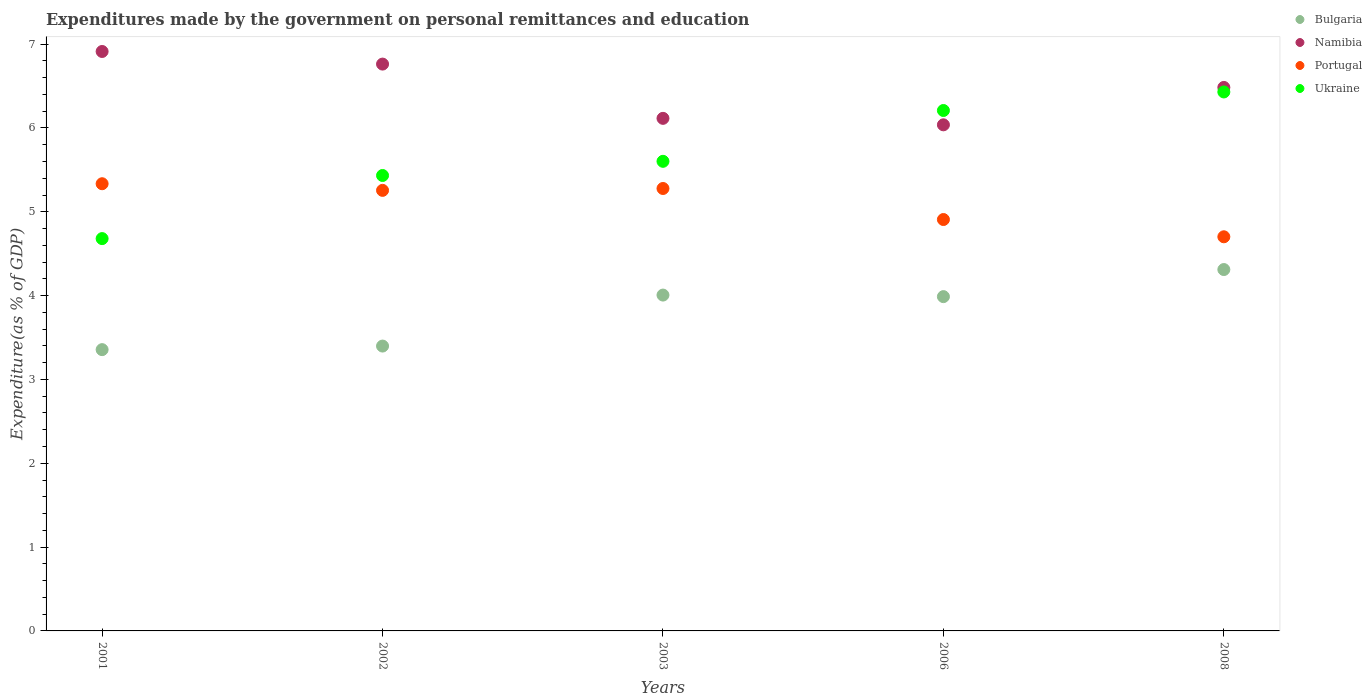How many different coloured dotlines are there?
Give a very brief answer. 4. Is the number of dotlines equal to the number of legend labels?
Make the answer very short. Yes. What is the expenditures made by the government on personal remittances and education in Bulgaria in 2008?
Give a very brief answer. 4.31. Across all years, what is the maximum expenditures made by the government on personal remittances and education in Bulgaria?
Keep it short and to the point. 4.31. Across all years, what is the minimum expenditures made by the government on personal remittances and education in Namibia?
Provide a short and direct response. 6.04. What is the total expenditures made by the government on personal remittances and education in Portugal in the graph?
Your response must be concise. 25.48. What is the difference between the expenditures made by the government on personal remittances and education in Namibia in 2002 and that in 2008?
Your answer should be compact. 0.28. What is the difference between the expenditures made by the government on personal remittances and education in Ukraine in 2003 and the expenditures made by the government on personal remittances and education in Bulgaria in 2001?
Your answer should be very brief. 2.25. What is the average expenditures made by the government on personal remittances and education in Namibia per year?
Make the answer very short. 6.46. In the year 2002, what is the difference between the expenditures made by the government on personal remittances and education in Portugal and expenditures made by the government on personal remittances and education in Namibia?
Give a very brief answer. -1.51. In how many years, is the expenditures made by the government on personal remittances and education in Ukraine greater than 6.2 %?
Your response must be concise. 2. What is the ratio of the expenditures made by the government on personal remittances and education in Bulgaria in 2002 to that in 2006?
Your answer should be compact. 0.85. Is the expenditures made by the government on personal remittances and education in Ukraine in 2001 less than that in 2002?
Your response must be concise. Yes. What is the difference between the highest and the second highest expenditures made by the government on personal remittances and education in Portugal?
Offer a very short reply. 0.06. What is the difference between the highest and the lowest expenditures made by the government on personal remittances and education in Bulgaria?
Your answer should be very brief. 0.96. Is it the case that in every year, the sum of the expenditures made by the government on personal remittances and education in Namibia and expenditures made by the government on personal remittances and education in Bulgaria  is greater than the sum of expenditures made by the government on personal remittances and education in Ukraine and expenditures made by the government on personal remittances and education in Portugal?
Your response must be concise. No. How many dotlines are there?
Offer a very short reply. 4. How many years are there in the graph?
Make the answer very short. 5. Are the values on the major ticks of Y-axis written in scientific E-notation?
Provide a short and direct response. No. Does the graph contain grids?
Provide a succinct answer. No. Where does the legend appear in the graph?
Offer a terse response. Top right. How many legend labels are there?
Keep it short and to the point. 4. What is the title of the graph?
Your response must be concise. Expenditures made by the government on personal remittances and education. Does "Saudi Arabia" appear as one of the legend labels in the graph?
Offer a terse response. No. What is the label or title of the Y-axis?
Offer a terse response. Expenditure(as % of GDP). What is the Expenditure(as % of GDP) in Bulgaria in 2001?
Your answer should be very brief. 3.36. What is the Expenditure(as % of GDP) in Namibia in 2001?
Your response must be concise. 6.91. What is the Expenditure(as % of GDP) of Portugal in 2001?
Your response must be concise. 5.34. What is the Expenditure(as % of GDP) of Ukraine in 2001?
Provide a short and direct response. 4.68. What is the Expenditure(as % of GDP) of Bulgaria in 2002?
Offer a terse response. 3.4. What is the Expenditure(as % of GDP) of Namibia in 2002?
Keep it short and to the point. 6.76. What is the Expenditure(as % of GDP) in Portugal in 2002?
Your response must be concise. 5.26. What is the Expenditure(as % of GDP) of Ukraine in 2002?
Give a very brief answer. 5.43. What is the Expenditure(as % of GDP) in Bulgaria in 2003?
Keep it short and to the point. 4.01. What is the Expenditure(as % of GDP) of Namibia in 2003?
Your answer should be compact. 6.12. What is the Expenditure(as % of GDP) of Portugal in 2003?
Provide a succinct answer. 5.28. What is the Expenditure(as % of GDP) of Ukraine in 2003?
Offer a terse response. 5.6. What is the Expenditure(as % of GDP) of Bulgaria in 2006?
Provide a short and direct response. 3.99. What is the Expenditure(as % of GDP) in Namibia in 2006?
Keep it short and to the point. 6.04. What is the Expenditure(as % of GDP) in Portugal in 2006?
Your answer should be very brief. 4.91. What is the Expenditure(as % of GDP) of Ukraine in 2006?
Your answer should be very brief. 6.21. What is the Expenditure(as % of GDP) in Bulgaria in 2008?
Make the answer very short. 4.31. What is the Expenditure(as % of GDP) of Namibia in 2008?
Provide a short and direct response. 6.48. What is the Expenditure(as % of GDP) of Portugal in 2008?
Your answer should be very brief. 4.7. What is the Expenditure(as % of GDP) in Ukraine in 2008?
Make the answer very short. 6.43. Across all years, what is the maximum Expenditure(as % of GDP) in Bulgaria?
Give a very brief answer. 4.31. Across all years, what is the maximum Expenditure(as % of GDP) of Namibia?
Give a very brief answer. 6.91. Across all years, what is the maximum Expenditure(as % of GDP) in Portugal?
Your answer should be very brief. 5.34. Across all years, what is the maximum Expenditure(as % of GDP) of Ukraine?
Keep it short and to the point. 6.43. Across all years, what is the minimum Expenditure(as % of GDP) of Bulgaria?
Make the answer very short. 3.36. Across all years, what is the minimum Expenditure(as % of GDP) in Namibia?
Make the answer very short. 6.04. Across all years, what is the minimum Expenditure(as % of GDP) of Portugal?
Keep it short and to the point. 4.7. Across all years, what is the minimum Expenditure(as % of GDP) in Ukraine?
Your response must be concise. 4.68. What is the total Expenditure(as % of GDP) of Bulgaria in the graph?
Your response must be concise. 19.06. What is the total Expenditure(as % of GDP) in Namibia in the graph?
Your response must be concise. 32.31. What is the total Expenditure(as % of GDP) of Portugal in the graph?
Offer a terse response. 25.48. What is the total Expenditure(as % of GDP) in Ukraine in the graph?
Your answer should be very brief. 28.35. What is the difference between the Expenditure(as % of GDP) in Bulgaria in 2001 and that in 2002?
Provide a succinct answer. -0.04. What is the difference between the Expenditure(as % of GDP) in Namibia in 2001 and that in 2002?
Your answer should be compact. 0.15. What is the difference between the Expenditure(as % of GDP) in Portugal in 2001 and that in 2002?
Ensure brevity in your answer.  0.08. What is the difference between the Expenditure(as % of GDP) in Ukraine in 2001 and that in 2002?
Keep it short and to the point. -0.75. What is the difference between the Expenditure(as % of GDP) of Bulgaria in 2001 and that in 2003?
Your response must be concise. -0.65. What is the difference between the Expenditure(as % of GDP) in Namibia in 2001 and that in 2003?
Your answer should be compact. 0.8. What is the difference between the Expenditure(as % of GDP) of Portugal in 2001 and that in 2003?
Your answer should be very brief. 0.06. What is the difference between the Expenditure(as % of GDP) in Ukraine in 2001 and that in 2003?
Offer a very short reply. -0.92. What is the difference between the Expenditure(as % of GDP) of Bulgaria in 2001 and that in 2006?
Keep it short and to the point. -0.63. What is the difference between the Expenditure(as % of GDP) in Portugal in 2001 and that in 2006?
Give a very brief answer. 0.43. What is the difference between the Expenditure(as % of GDP) in Ukraine in 2001 and that in 2006?
Keep it short and to the point. -1.53. What is the difference between the Expenditure(as % of GDP) in Bulgaria in 2001 and that in 2008?
Provide a short and direct response. -0.96. What is the difference between the Expenditure(as % of GDP) in Namibia in 2001 and that in 2008?
Offer a very short reply. 0.43. What is the difference between the Expenditure(as % of GDP) in Portugal in 2001 and that in 2008?
Offer a terse response. 0.63. What is the difference between the Expenditure(as % of GDP) of Ukraine in 2001 and that in 2008?
Your answer should be very brief. -1.75. What is the difference between the Expenditure(as % of GDP) in Bulgaria in 2002 and that in 2003?
Offer a very short reply. -0.61. What is the difference between the Expenditure(as % of GDP) of Namibia in 2002 and that in 2003?
Offer a very short reply. 0.65. What is the difference between the Expenditure(as % of GDP) of Portugal in 2002 and that in 2003?
Provide a succinct answer. -0.02. What is the difference between the Expenditure(as % of GDP) in Ukraine in 2002 and that in 2003?
Offer a terse response. -0.17. What is the difference between the Expenditure(as % of GDP) in Bulgaria in 2002 and that in 2006?
Offer a terse response. -0.59. What is the difference between the Expenditure(as % of GDP) in Namibia in 2002 and that in 2006?
Provide a short and direct response. 0.72. What is the difference between the Expenditure(as % of GDP) of Portugal in 2002 and that in 2006?
Provide a short and direct response. 0.35. What is the difference between the Expenditure(as % of GDP) in Ukraine in 2002 and that in 2006?
Provide a short and direct response. -0.78. What is the difference between the Expenditure(as % of GDP) of Bulgaria in 2002 and that in 2008?
Make the answer very short. -0.91. What is the difference between the Expenditure(as % of GDP) of Namibia in 2002 and that in 2008?
Provide a short and direct response. 0.28. What is the difference between the Expenditure(as % of GDP) of Portugal in 2002 and that in 2008?
Your response must be concise. 0.55. What is the difference between the Expenditure(as % of GDP) in Ukraine in 2002 and that in 2008?
Your answer should be compact. -1. What is the difference between the Expenditure(as % of GDP) of Bulgaria in 2003 and that in 2006?
Give a very brief answer. 0.02. What is the difference between the Expenditure(as % of GDP) of Namibia in 2003 and that in 2006?
Provide a short and direct response. 0.08. What is the difference between the Expenditure(as % of GDP) of Portugal in 2003 and that in 2006?
Provide a short and direct response. 0.37. What is the difference between the Expenditure(as % of GDP) of Ukraine in 2003 and that in 2006?
Your response must be concise. -0.61. What is the difference between the Expenditure(as % of GDP) of Bulgaria in 2003 and that in 2008?
Ensure brevity in your answer.  -0.3. What is the difference between the Expenditure(as % of GDP) of Namibia in 2003 and that in 2008?
Offer a terse response. -0.37. What is the difference between the Expenditure(as % of GDP) of Portugal in 2003 and that in 2008?
Give a very brief answer. 0.58. What is the difference between the Expenditure(as % of GDP) in Ukraine in 2003 and that in 2008?
Your answer should be very brief. -0.83. What is the difference between the Expenditure(as % of GDP) of Bulgaria in 2006 and that in 2008?
Offer a terse response. -0.32. What is the difference between the Expenditure(as % of GDP) of Namibia in 2006 and that in 2008?
Your answer should be compact. -0.45. What is the difference between the Expenditure(as % of GDP) in Portugal in 2006 and that in 2008?
Offer a very short reply. 0.21. What is the difference between the Expenditure(as % of GDP) of Ukraine in 2006 and that in 2008?
Your answer should be very brief. -0.22. What is the difference between the Expenditure(as % of GDP) of Bulgaria in 2001 and the Expenditure(as % of GDP) of Namibia in 2002?
Your answer should be very brief. -3.41. What is the difference between the Expenditure(as % of GDP) of Bulgaria in 2001 and the Expenditure(as % of GDP) of Portugal in 2002?
Provide a succinct answer. -1.9. What is the difference between the Expenditure(as % of GDP) in Bulgaria in 2001 and the Expenditure(as % of GDP) in Ukraine in 2002?
Keep it short and to the point. -2.08. What is the difference between the Expenditure(as % of GDP) of Namibia in 2001 and the Expenditure(as % of GDP) of Portugal in 2002?
Ensure brevity in your answer.  1.66. What is the difference between the Expenditure(as % of GDP) in Namibia in 2001 and the Expenditure(as % of GDP) in Ukraine in 2002?
Give a very brief answer. 1.48. What is the difference between the Expenditure(as % of GDP) of Portugal in 2001 and the Expenditure(as % of GDP) of Ukraine in 2002?
Keep it short and to the point. -0.1. What is the difference between the Expenditure(as % of GDP) in Bulgaria in 2001 and the Expenditure(as % of GDP) in Namibia in 2003?
Offer a terse response. -2.76. What is the difference between the Expenditure(as % of GDP) of Bulgaria in 2001 and the Expenditure(as % of GDP) of Portugal in 2003?
Offer a terse response. -1.92. What is the difference between the Expenditure(as % of GDP) of Bulgaria in 2001 and the Expenditure(as % of GDP) of Ukraine in 2003?
Your response must be concise. -2.25. What is the difference between the Expenditure(as % of GDP) in Namibia in 2001 and the Expenditure(as % of GDP) in Portugal in 2003?
Keep it short and to the point. 1.63. What is the difference between the Expenditure(as % of GDP) of Namibia in 2001 and the Expenditure(as % of GDP) of Ukraine in 2003?
Your answer should be very brief. 1.31. What is the difference between the Expenditure(as % of GDP) of Portugal in 2001 and the Expenditure(as % of GDP) of Ukraine in 2003?
Your answer should be very brief. -0.27. What is the difference between the Expenditure(as % of GDP) of Bulgaria in 2001 and the Expenditure(as % of GDP) of Namibia in 2006?
Ensure brevity in your answer.  -2.68. What is the difference between the Expenditure(as % of GDP) of Bulgaria in 2001 and the Expenditure(as % of GDP) of Portugal in 2006?
Provide a succinct answer. -1.55. What is the difference between the Expenditure(as % of GDP) of Bulgaria in 2001 and the Expenditure(as % of GDP) of Ukraine in 2006?
Your answer should be very brief. -2.85. What is the difference between the Expenditure(as % of GDP) of Namibia in 2001 and the Expenditure(as % of GDP) of Portugal in 2006?
Keep it short and to the point. 2. What is the difference between the Expenditure(as % of GDP) in Namibia in 2001 and the Expenditure(as % of GDP) in Ukraine in 2006?
Your answer should be very brief. 0.7. What is the difference between the Expenditure(as % of GDP) of Portugal in 2001 and the Expenditure(as % of GDP) of Ukraine in 2006?
Keep it short and to the point. -0.87. What is the difference between the Expenditure(as % of GDP) of Bulgaria in 2001 and the Expenditure(as % of GDP) of Namibia in 2008?
Your answer should be very brief. -3.13. What is the difference between the Expenditure(as % of GDP) of Bulgaria in 2001 and the Expenditure(as % of GDP) of Portugal in 2008?
Keep it short and to the point. -1.35. What is the difference between the Expenditure(as % of GDP) in Bulgaria in 2001 and the Expenditure(as % of GDP) in Ukraine in 2008?
Your answer should be very brief. -3.07. What is the difference between the Expenditure(as % of GDP) in Namibia in 2001 and the Expenditure(as % of GDP) in Portugal in 2008?
Your answer should be compact. 2.21. What is the difference between the Expenditure(as % of GDP) of Namibia in 2001 and the Expenditure(as % of GDP) of Ukraine in 2008?
Your answer should be compact. 0.48. What is the difference between the Expenditure(as % of GDP) of Portugal in 2001 and the Expenditure(as % of GDP) of Ukraine in 2008?
Offer a very short reply. -1.09. What is the difference between the Expenditure(as % of GDP) of Bulgaria in 2002 and the Expenditure(as % of GDP) of Namibia in 2003?
Provide a short and direct response. -2.72. What is the difference between the Expenditure(as % of GDP) of Bulgaria in 2002 and the Expenditure(as % of GDP) of Portugal in 2003?
Your answer should be very brief. -1.88. What is the difference between the Expenditure(as % of GDP) in Bulgaria in 2002 and the Expenditure(as % of GDP) in Ukraine in 2003?
Your answer should be compact. -2.2. What is the difference between the Expenditure(as % of GDP) in Namibia in 2002 and the Expenditure(as % of GDP) in Portugal in 2003?
Offer a terse response. 1.48. What is the difference between the Expenditure(as % of GDP) of Namibia in 2002 and the Expenditure(as % of GDP) of Ukraine in 2003?
Provide a short and direct response. 1.16. What is the difference between the Expenditure(as % of GDP) in Portugal in 2002 and the Expenditure(as % of GDP) in Ukraine in 2003?
Your answer should be compact. -0.35. What is the difference between the Expenditure(as % of GDP) in Bulgaria in 2002 and the Expenditure(as % of GDP) in Namibia in 2006?
Provide a succinct answer. -2.64. What is the difference between the Expenditure(as % of GDP) in Bulgaria in 2002 and the Expenditure(as % of GDP) in Portugal in 2006?
Keep it short and to the point. -1.51. What is the difference between the Expenditure(as % of GDP) in Bulgaria in 2002 and the Expenditure(as % of GDP) in Ukraine in 2006?
Offer a terse response. -2.81. What is the difference between the Expenditure(as % of GDP) of Namibia in 2002 and the Expenditure(as % of GDP) of Portugal in 2006?
Offer a terse response. 1.85. What is the difference between the Expenditure(as % of GDP) of Namibia in 2002 and the Expenditure(as % of GDP) of Ukraine in 2006?
Your answer should be very brief. 0.55. What is the difference between the Expenditure(as % of GDP) of Portugal in 2002 and the Expenditure(as % of GDP) of Ukraine in 2006?
Provide a succinct answer. -0.95. What is the difference between the Expenditure(as % of GDP) of Bulgaria in 2002 and the Expenditure(as % of GDP) of Namibia in 2008?
Give a very brief answer. -3.09. What is the difference between the Expenditure(as % of GDP) of Bulgaria in 2002 and the Expenditure(as % of GDP) of Portugal in 2008?
Offer a very short reply. -1.3. What is the difference between the Expenditure(as % of GDP) in Bulgaria in 2002 and the Expenditure(as % of GDP) in Ukraine in 2008?
Offer a very short reply. -3.03. What is the difference between the Expenditure(as % of GDP) of Namibia in 2002 and the Expenditure(as % of GDP) of Portugal in 2008?
Provide a succinct answer. 2.06. What is the difference between the Expenditure(as % of GDP) of Namibia in 2002 and the Expenditure(as % of GDP) of Ukraine in 2008?
Your answer should be compact. 0.33. What is the difference between the Expenditure(as % of GDP) of Portugal in 2002 and the Expenditure(as % of GDP) of Ukraine in 2008?
Your answer should be very brief. -1.17. What is the difference between the Expenditure(as % of GDP) in Bulgaria in 2003 and the Expenditure(as % of GDP) in Namibia in 2006?
Give a very brief answer. -2.03. What is the difference between the Expenditure(as % of GDP) of Bulgaria in 2003 and the Expenditure(as % of GDP) of Portugal in 2006?
Your answer should be very brief. -0.9. What is the difference between the Expenditure(as % of GDP) of Bulgaria in 2003 and the Expenditure(as % of GDP) of Ukraine in 2006?
Offer a terse response. -2.2. What is the difference between the Expenditure(as % of GDP) of Namibia in 2003 and the Expenditure(as % of GDP) of Portugal in 2006?
Keep it short and to the point. 1.21. What is the difference between the Expenditure(as % of GDP) of Namibia in 2003 and the Expenditure(as % of GDP) of Ukraine in 2006?
Your response must be concise. -0.09. What is the difference between the Expenditure(as % of GDP) of Portugal in 2003 and the Expenditure(as % of GDP) of Ukraine in 2006?
Keep it short and to the point. -0.93. What is the difference between the Expenditure(as % of GDP) of Bulgaria in 2003 and the Expenditure(as % of GDP) of Namibia in 2008?
Offer a very short reply. -2.48. What is the difference between the Expenditure(as % of GDP) in Bulgaria in 2003 and the Expenditure(as % of GDP) in Portugal in 2008?
Give a very brief answer. -0.7. What is the difference between the Expenditure(as % of GDP) of Bulgaria in 2003 and the Expenditure(as % of GDP) of Ukraine in 2008?
Offer a very short reply. -2.42. What is the difference between the Expenditure(as % of GDP) in Namibia in 2003 and the Expenditure(as % of GDP) in Portugal in 2008?
Provide a succinct answer. 1.41. What is the difference between the Expenditure(as % of GDP) in Namibia in 2003 and the Expenditure(as % of GDP) in Ukraine in 2008?
Your answer should be compact. -0.31. What is the difference between the Expenditure(as % of GDP) of Portugal in 2003 and the Expenditure(as % of GDP) of Ukraine in 2008?
Ensure brevity in your answer.  -1.15. What is the difference between the Expenditure(as % of GDP) in Bulgaria in 2006 and the Expenditure(as % of GDP) in Namibia in 2008?
Give a very brief answer. -2.5. What is the difference between the Expenditure(as % of GDP) in Bulgaria in 2006 and the Expenditure(as % of GDP) in Portugal in 2008?
Your response must be concise. -0.71. What is the difference between the Expenditure(as % of GDP) in Bulgaria in 2006 and the Expenditure(as % of GDP) in Ukraine in 2008?
Your answer should be compact. -2.44. What is the difference between the Expenditure(as % of GDP) in Namibia in 2006 and the Expenditure(as % of GDP) in Portugal in 2008?
Make the answer very short. 1.34. What is the difference between the Expenditure(as % of GDP) in Namibia in 2006 and the Expenditure(as % of GDP) in Ukraine in 2008?
Your response must be concise. -0.39. What is the difference between the Expenditure(as % of GDP) in Portugal in 2006 and the Expenditure(as % of GDP) in Ukraine in 2008?
Provide a succinct answer. -1.52. What is the average Expenditure(as % of GDP) of Bulgaria per year?
Ensure brevity in your answer.  3.81. What is the average Expenditure(as % of GDP) of Namibia per year?
Your answer should be compact. 6.46. What is the average Expenditure(as % of GDP) in Portugal per year?
Your answer should be very brief. 5.1. What is the average Expenditure(as % of GDP) of Ukraine per year?
Your response must be concise. 5.67. In the year 2001, what is the difference between the Expenditure(as % of GDP) in Bulgaria and Expenditure(as % of GDP) in Namibia?
Your answer should be very brief. -3.56. In the year 2001, what is the difference between the Expenditure(as % of GDP) of Bulgaria and Expenditure(as % of GDP) of Portugal?
Your answer should be very brief. -1.98. In the year 2001, what is the difference between the Expenditure(as % of GDP) in Bulgaria and Expenditure(as % of GDP) in Ukraine?
Provide a short and direct response. -1.32. In the year 2001, what is the difference between the Expenditure(as % of GDP) of Namibia and Expenditure(as % of GDP) of Portugal?
Your answer should be very brief. 1.58. In the year 2001, what is the difference between the Expenditure(as % of GDP) in Namibia and Expenditure(as % of GDP) in Ukraine?
Keep it short and to the point. 2.23. In the year 2001, what is the difference between the Expenditure(as % of GDP) of Portugal and Expenditure(as % of GDP) of Ukraine?
Offer a terse response. 0.65. In the year 2002, what is the difference between the Expenditure(as % of GDP) in Bulgaria and Expenditure(as % of GDP) in Namibia?
Give a very brief answer. -3.36. In the year 2002, what is the difference between the Expenditure(as % of GDP) in Bulgaria and Expenditure(as % of GDP) in Portugal?
Make the answer very short. -1.86. In the year 2002, what is the difference between the Expenditure(as % of GDP) of Bulgaria and Expenditure(as % of GDP) of Ukraine?
Provide a succinct answer. -2.03. In the year 2002, what is the difference between the Expenditure(as % of GDP) of Namibia and Expenditure(as % of GDP) of Portugal?
Provide a succinct answer. 1.51. In the year 2002, what is the difference between the Expenditure(as % of GDP) in Namibia and Expenditure(as % of GDP) in Ukraine?
Offer a very short reply. 1.33. In the year 2002, what is the difference between the Expenditure(as % of GDP) in Portugal and Expenditure(as % of GDP) in Ukraine?
Give a very brief answer. -0.18. In the year 2003, what is the difference between the Expenditure(as % of GDP) in Bulgaria and Expenditure(as % of GDP) in Namibia?
Make the answer very short. -2.11. In the year 2003, what is the difference between the Expenditure(as % of GDP) of Bulgaria and Expenditure(as % of GDP) of Portugal?
Keep it short and to the point. -1.27. In the year 2003, what is the difference between the Expenditure(as % of GDP) in Bulgaria and Expenditure(as % of GDP) in Ukraine?
Make the answer very short. -1.6. In the year 2003, what is the difference between the Expenditure(as % of GDP) of Namibia and Expenditure(as % of GDP) of Portugal?
Provide a succinct answer. 0.84. In the year 2003, what is the difference between the Expenditure(as % of GDP) in Namibia and Expenditure(as % of GDP) in Ukraine?
Make the answer very short. 0.51. In the year 2003, what is the difference between the Expenditure(as % of GDP) in Portugal and Expenditure(as % of GDP) in Ukraine?
Provide a succinct answer. -0.32. In the year 2006, what is the difference between the Expenditure(as % of GDP) in Bulgaria and Expenditure(as % of GDP) in Namibia?
Offer a terse response. -2.05. In the year 2006, what is the difference between the Expenditure(as % of GDP) of Bulgaria and Expenditure(as % of GDP) of Portugal?
Provide a short and direct response. -0.92. In the year 2006, what is the difference between the Expenditure(as % of GDP) in Bulgaria and Expenditure(as % of GDP) in Ukraine?
Offer a terse response. -2.22. In the year 2006, what is the difference between the Expenditure(as % of GDP) in Namibia and Expenditure(as % of GDP) in Portugal?
Your answer should be very brief. 1.13. In the year 2006, what is the difference between the Expenditure(as % of GDP) of Namibia and Expenditure(as % of GDP) of Ukraine?
Ensure brevity in your answer.  -0.17. In the year 2006, what is the difference between the Expenditure(as % of GDP) in Portugal and Expenditure(as % of GDP) in Ukraine?
Offer a terse response. -1.3. In the year 2008, what is the difference between the Expenditure(as % of GDP) of Bulgaria and Expenditure(as % of GDP) of Namibia?
Give a very brief answer. -2.17. In the year 2008, what is the difference between the Expenditure(as % of GDP) of Bulgaria and Expenditure(as % of GDP) of Portugal?
Ensure brevity in your answer.  -0.39. In the year 2008, what is the difference between the Expenditure(as % of GDP) in Bulgaria and Expenditure(as % of GDP) in Ukraine?
Your answer should be very brief. -2.12. In the year 2008, what is the difference between the Expenditure(as % of GDP) of Namibia and Expenditure(as % of GDP) of Portugal?
Offer a very short reply. 1.78. In the year 2008, what is the difference between the Expenditure(as % of GDP) in Namibia and Expenditure(as % of GDP) in Ukraine?
Keep it short and to the point. 0.05. In the year 2008, what is the difference between the Expenditure(as % of GDP) of Portugal and Expenditure(as % of GDP) of Ukraine?
Provide a succinct answer. -1.73. What is the ratio of the Expenditure(as % of GDP) of Bulgaria in 2001 to that in 2002?
Keep it short and to the point. 0.99. What is the ratio of the Expenditure(as % of GDP) of Namibia in 2001 to that in 2002?
Your answer should be very brief. 1.02. What is the ratio of the Expenditure(as % of GDP) of Portugal in 2001 to that in 2002?
Keep it short and to the point. 1.02. What is the ratio of the Expenditure(as % of GDP) in Ukraine in 2001 to that in 2002?
Make the answer very short. 0.86. What is the ratio of the Expenditure(as % of GDP) of Bulgaria in 2001 to that in 2003?
Your answer should be compact. 0.84. What is the ratio of the Expenditure(as % of GDP) of Namibia in 2001 to that in 2003?
Keep it short and to the point. 1.13. What is the ratio of the Expenditure(as % of GDP) of Portugal in 2001 to that in 2003?
Ensure brevity in your answer.  1.01. What is the ratio of the Expenditure(as % of GDP) in Ukraine in 2001 to that in 2003?
Offer a very short reply. 0.84. What is the ratio of the Expenditure(as % of GDP) of Bulgaria in 2001 to that in 2006?
Offer a very short reply. 0.84. What is the ratio of the Expenditure(as % of GDP) of Namibia in 2001 to that in 2006?
Give a very brief answer. 1.14. What is the ratio of the Expenditure(as % of GDP) of Portugal in 2001 to that in 2006?
Your answer should be compact. 1.09. What is the ratio of the Expenditure(as % of GDP) of Ukraine in 2001 to that in 2006?
Offer a very short reply. 0.75. What is the ratio of the Expenditure(as % of GDP) of Bulgaria in 2001 to that in 2008?
Provide a succinct answer. 0.78. What is the ratio of the Expenditure(as % of GDP) of Namibia in 2001 to that in 2008?
Provide a succinct answer. 1.07. What is the ratio of the Expenditure(as % of GDP) in Portugal in 2001 to that in 2008?
Offer a terse response. 1.13. What is the ratio of the Expenditure(as % of GDP) of Ukraine in 2001 to that in 2008?
Your response must be concise. 0.73. What is the ratio of the Expenditure(as % of GDP) in Bulgaria in 2002 to that in 2003?
Offer a terse response. 0.85. What is the ratio of the Expenditure(as % of GDP) in Namibia in 2002 to that in 2003?
Provide a short and direct response. 1.11. What is the ratio of the Expenditure(as % of GDP) of Ukraine in 2002 to that in 2003?
Your answer should be very brief. 0.97. What is the ratio of the Expenditure(as % of GDP) of Bulgaria in 2002 to that in 2006?
Provide a short and direct response. 0.85. What is the ratio of the Expenditure(as % of GDP) of Namibia in 2002 to that in 2006?
Offer a very short reply. 1.12. What is the ratio of the Expenditure(as % of GDP) in Portugal in 2002 to that in 2006?
Keep it short and to the point. 1.07. What is the ratio of the Expenditure(as % of GDP) in Ukraine in 2002 to that in 2006?
Your answer should be compact. 0.88. What is the ratio of the Expenditure(as % of GDP) of Bulgaria in 2002 to that in 2008?
Offer a very short reply. 0.79. What is the ratio of the Expenditure(as % of GDP) in Namibia in 2002 to that in 2008?
Your answer should be compact. 1.04. What is the ratio of the Expenditure(as % of GDP) in Portugal in 2002 to that in 2008?
Offer a very short reply. 1.12. What is the ratio of the Expenditure(as % of GDP) in Ukraine in 2002 to that in 2008?
Offer a terse response. 0.84. What is the ratio of the Expenditure(as % of GDP) in Namibia in 2003 to that in 2006?
Give a very brief answer. 1.01. What is the ratio of the Expenditure(as % of GDP) of Portugal in 2003 to that in 2006?
Give a very brief answer. 1.08. What is the ratio of the Expenditure(as % of GDP) in Ukraine in 2003 to that in 2006?
Offer a terse response. 0.9. What is the ratio of the Expenditure(as % of GDP) in Bulgaria in 2003 to that in 2008?
Make the answer very short. 0.93. What is the ratio of the Expenditure(as % of GDP) in Namibia in 2003 to that in 2008?
Keep it short and to the point. 0.94. What is the ratio of the Expenditure(as % of GDP) in Portugal in 2003 to that in 2008?
Your answer should be compact. 1.12. What is the ratio of the Expenditure(as % of GDP) of Ukraine in 2003 to that in 2008?
Give a very brief answer. 0.87. What is the ratio of the Expenditure(as % of GDP) in Bulgaria in 2006 to that in 2008?
Give a very brief answer. 0.93. What is the ratio of the Expenditure(as % of GDP) of Namibia in 2006 to that in 2008?
Your answer should be compact. 0.93. What is the ratio of the Expenditure(as % of GDP) in Portugal in 2006 to that in 2008?
Your answer should be very brief. 1.04. What is the ratio of the Expenditure(as % of GDP) of Ukraine in 2006 to that in 2008?
Offer a very short reply. 0.97. What is the difference between the highest and the second highest Expenditure(as % of GDP) of Bulgaria?
Provide a succinct answer. 0.3. What is the difference between the highest and the second highest Expenditure(as % of GDP) of Namibia?
Ensure brevity in your answer.  0.15. What is the difference between the highest and the second highest Expenditure(as % of GDP) of Portugal?
Provide a succinct answer. 0.06. What is the difference between the highest and the second highest Expenditure(as % of GDP) of Ukraine?
Give a very brief answer. 0.22. What is the difference between the highest and the lowest Expenditure(as % of GDP) in Bulgaria?
Make the answer very short. 0.96. What is the difference between the highest and the lowest Expenditure(as % of GDP) of Namibia?
Ensure brevity in your answer.  0.88. What is the difference between the highest and the lowest Expenditure(as % of GDP) in Portugal?
Make the answer very short. 0.63. What is the difference between the highest and the lowest Expenditure(as % of GDP) in Ukraine?
Keep it short and to the point. 1.75. 